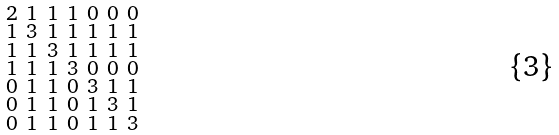<formula> <loc_0><loc_0><loc_500><loc_500>\begin{smallmatrix} 2 & 1 & 1 & 1 & 0 & 0 & 0 \\ 1 & 3 & 1 & 1 & 1 & 1 & 1 \\ 1 & 1 & 3 & 1 & 1 & 1 & 1 \\ 1 & 1 & 1 & 3 & 0 & 0 & 0 \\ 0 & 1 & 1 & 0 & 3 & 1 & 1 \\ 0 & 1 & 1 & 0 & 1 & 3 & 1 \\ 0 & 1 & 1 & 0 & 1 & 1 & 3 \end{smallmatrix}</formula> 